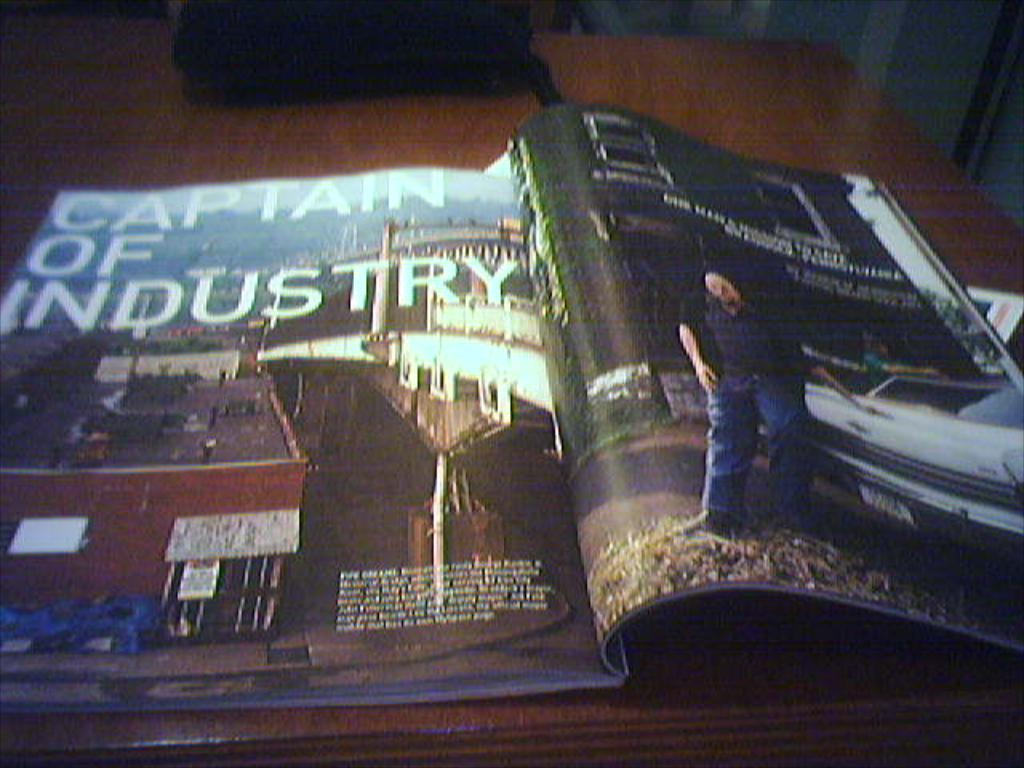<image>
Share a concise interpretation of the image provided. A magazine is opened and shows text that reads CAPTAIN OF INDUSTRY. 